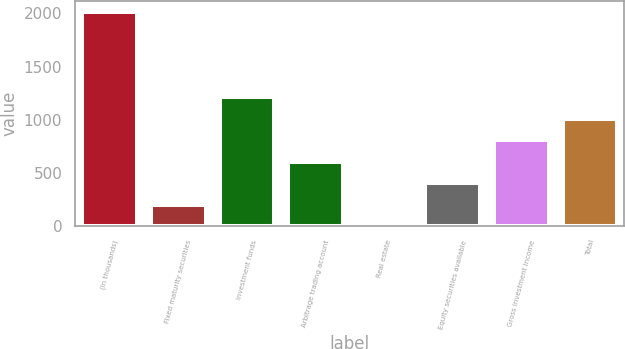Convert chart to OTSL. <chart><loc_0><loc_0><loc_500><loc_500><bar_chart><fcel>(In thousands)<fcel>Fixed maturity securities<fcel>Investment funds<fcel>Arbitrage trading account<fcel>Real estate<fcel>Equity securities available<fcel>Gross investment income<fcel>Total<nl><fcel>2014<fcel>202.75<fcel>1209<fcel>605.25<fcel>1.5<fcel>404<fcel>806.5<fcel>1007.75<nl></chart> 